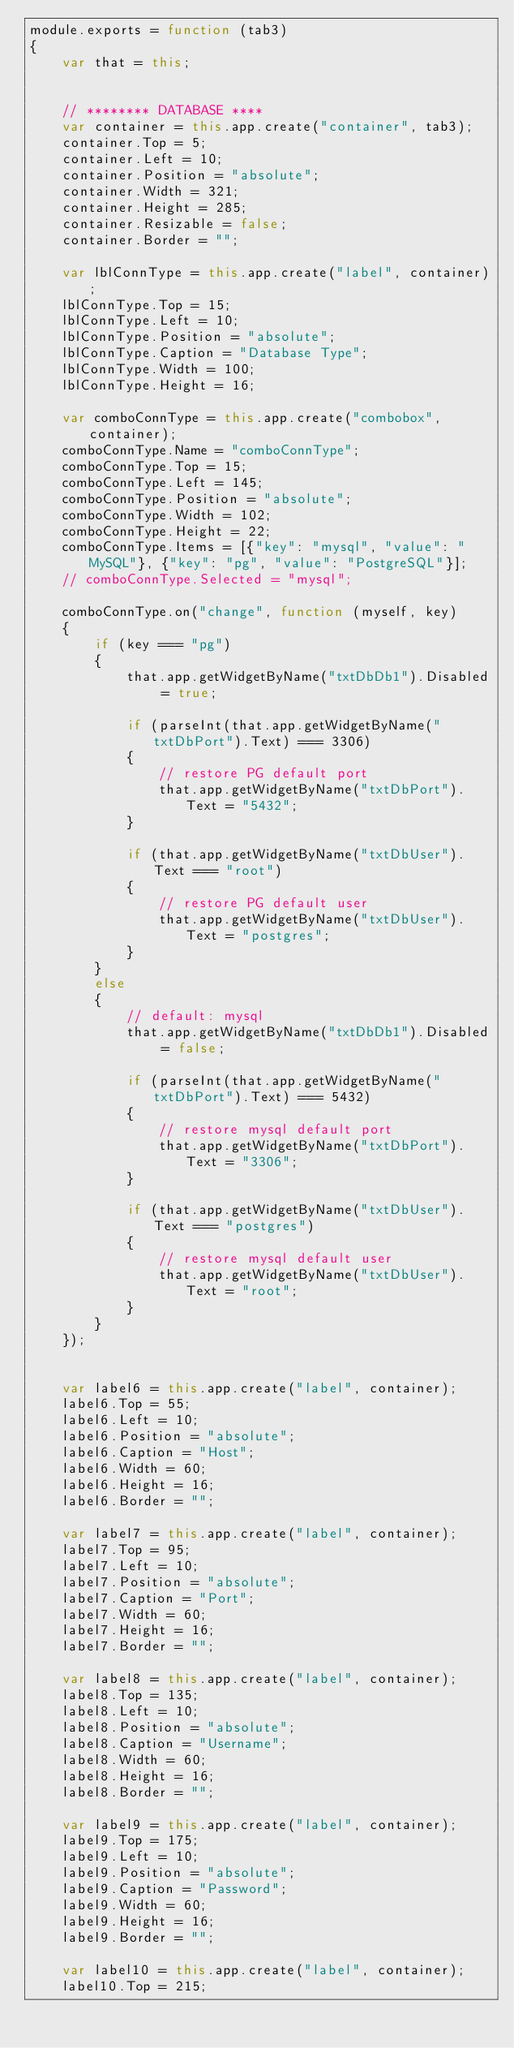Convert code to text. <code><loc_0><loc_0><loc_500><loc_500><_JavaScript_>module.exports = function (tab3)
{
    var that = this;


    // ******** DATABASE ****
    var container = this.app.create("container", tab3);
    container.Top = 5;
    container.Left = 10;
    container.Position = "absolute";
    container.Width = 321;
    container.Height = 285;
    container.Resizable = false;
    container.Border = "";

    var lblConnType = this.app.create("label", container);
    lblConnType.Top = 15;
    lblConnType.Left = 10;
    lblConnType.Position = "absolute";
    lblConnType.Caption = "Database Type";
    lblConnType.Width = 100;
    lblConnType.Height = 16;

    var comboConnType = this.app.create("combobox", container);
    comboConnType.Name = "comboConnType";
    comboConnType.Top = 15;
    comboConnType.Left = 145;
    comboConnType.Position = "absolute";
    comboConnType.Width = 102;
    comboConnType.Height = 22;
    comboConnType.Items = [{"key": "mysql", "value": "MySQL"}, {"key": "pg", "value": "PostgreSQL"}];
    // comboConnType.Selected = "mysql";

    comboConnType.on("change", function (myself, key)
    {
        if (key === "pg")
        {
            that.app.getWidgetByName("txtDbDb1").Disabled = true;

            if (parseInt(that.app.getWidgetByName("txtDbPort").Text) === 3306)
            {
                // restore PG default port
                that.app.getWidgetByName("txtDbPort").Text = "5432";
            }

            if (that.app.getWidgetByName("txtDbUser").Text === "root")
            {
                // restore PG default user
                that.app.getWidgetByName("txtDbUser").Text = "postgres";
            }
        }
        else
        {
            // default: mysql
            that.app.getWidgetByName("txtDbDb1").Disabled = false;

            if (parseInt(that.app.getWidgetByName("txtDbPort").Text) === 5432)
            {
                // restore mysql default port
                that.app.getWidgetByName("txtDbPort").Text = "3306";
            }

            if (that.app.getWidgetByName("txtDbUser").Text === "postgres")
            {
                // restore mysql default user
                that.app.getWidgetByName("txtDbUser").Text = "root";
            }
        }
    });


    var label6 = this.app.create("label", container);
    label6.Top = 55;
    label6.Left = 10;
    label6.Position = "absolute";
    label6.Caption = "Host";
    label6.Width = 60;
    label6.Height = 16;
    label6.Border = "";

    var label7 = this.app.create("label", container);
    label7.Top = 95;
    label7.Left = 10;
    label7.Position = "absolute";
    label7.Caption = "Port";
    label7.Width = 60;
    label7.Height = 16;
    label7.Border = "";

    var label8 = this.app.create("label", container);
    label8.Top = 135;
    label8.Left = 10;
    label8.Position = "absolute";
    label8.Caption = "Username";
    label8.Width = 60;
    label8.Height = 16;
    label8.Border = "";

    var label9 = this.app.create("label", container);
    label9.Top = 175;
    label9.Left = 10;
    label9.Position = "absolute";
    label9.Caption = "Password";
    label9.Width = 60;
    label9.Height = 16;
    label9.Border = "";

    var label10 = this.app.create("label", container);
    label10.Top = 215;</code> 